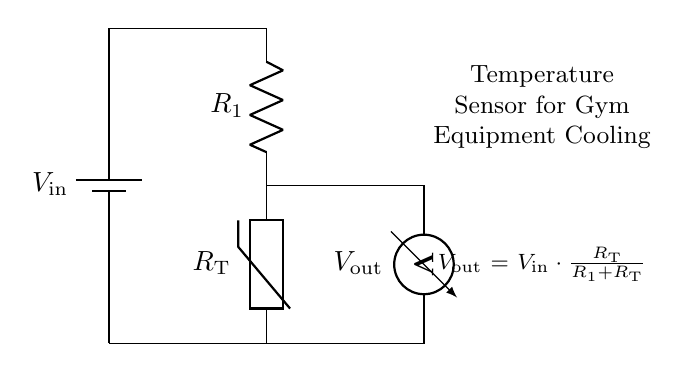What components are present in this circuit? The circuit consists of a battery, a resistor, and a thermistor, which are standard components in a voltage divider configuration used for sensing temperature.
Answer: battery, resistor, thermistor What is the purpose of the thermistor in this circuit? The thermistor acts as a temperature-dependent resistor, changing its resistance with temperature variations, allowing the circuit to sense temperature and regulate the cooling system accordingly.
Answer: temperature sensing What is the formula for the output voltage in this circuit? The output voltage is calculated using the voltage divider formula, which is stated on the diagram as Vout = Vin * (RT / (R1 + RT)). This relationship indicates how the input voltage is divided between the resistor and the thermistor.
Answer: Vout = Vin * (RT / (R1 + RT)) Which component determines the output voltage based on temperature changes? The thermistor's resistance (RT) varies with temperature, directly influencing the output voltage (Vout) by changing the division of the input voltage across the resistors in the circuit.
Answer: thermistor What would happen to the output voltage if the temperature increases? If the temperature increases, the resistance of the thermistor decreases, causing the output voltage (Vout) to rise due to a larger proportion of the input voltage being dropped across the thermistor as R1 stays constant.
Answer: output voltage increases What type of circuit is this? This is a voltage divider circuit, as it divides the input voltage into smaller output voltages based on the resistance values of its components.
Answer: voltage divider 